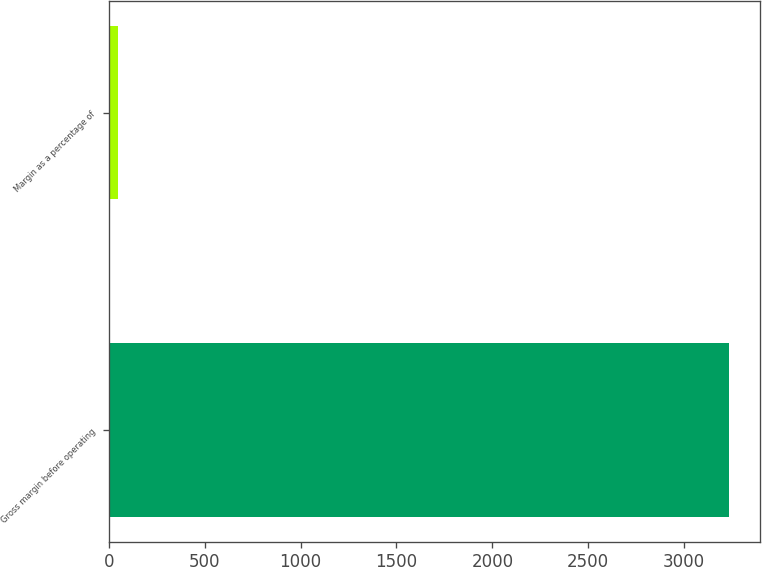Convert chart to OTSL. <chart><loc_0><loc_0><loc_500><loc_500><bar_chart><fcel>Gross margin before operating<fcel>Margin as a percentage of<nl><fcel>3236<fcel>46<nl></chart> 